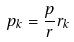<formula> <loc_0><loc_0><loc_500><loc_500>p _ { k } = \frac { p } { r } r _ { k }</formula> 